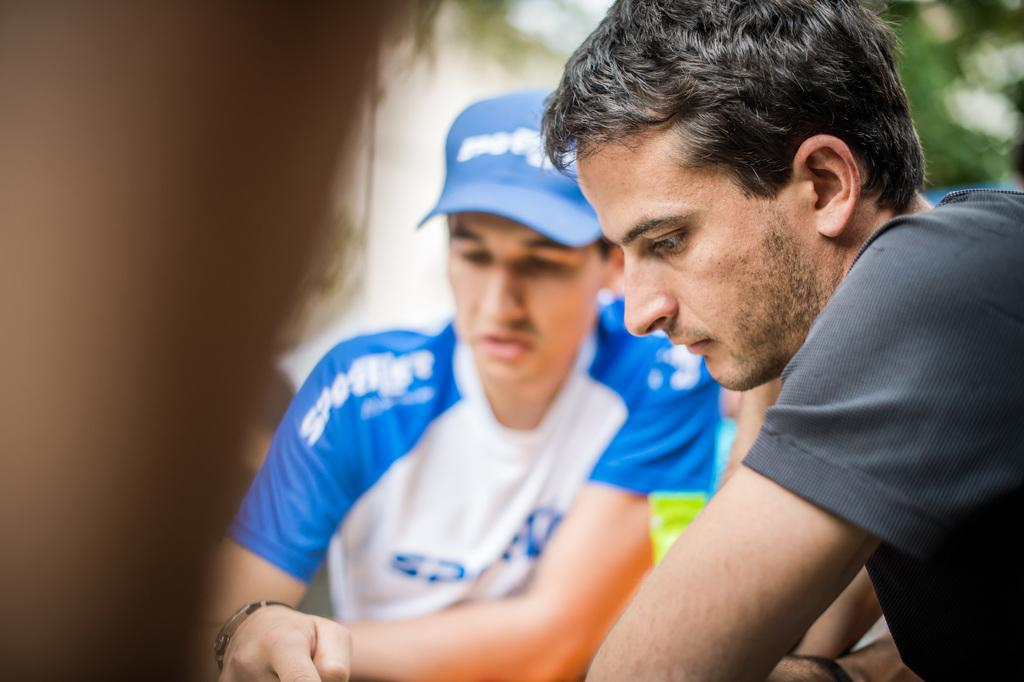How many people are in the image? There are two men in the image. Can you describe the clothing of one of the men? One of the men is wearing a cap. What is the condition of the area around the men? The area around the men is blurry. What type of lock can be seen on the boat in the image? There is no boat or lock present in the image; it features two men. Can you describe the wren that is perched on the shoulder of one of the men in the image? There is no wren present in the image; it only features two men. 